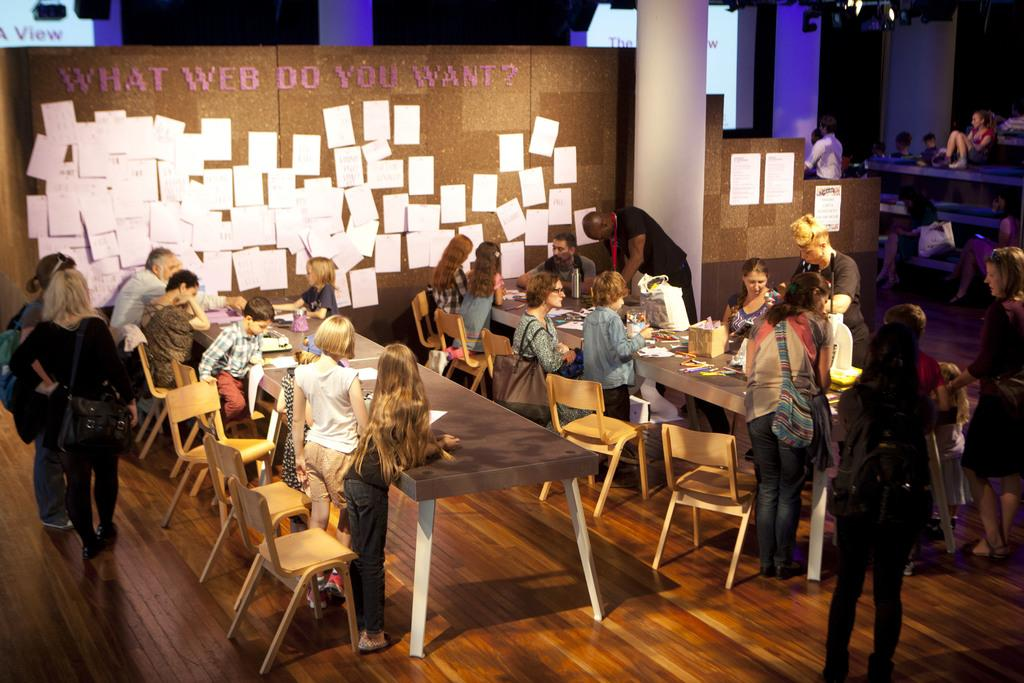How many people are in the image? There are people in the image, but the exact number is not specified. What are the people in the image doing? Some people are sitting, while others are standing. What type of furniture is present in the image? There are chairs and tables in the image. What can be seen in the background of the image? Papers are visible in the background of the image. How many apples are on the table in the image? There is no mention of apples in the image, so we cannot determine the number of apples present. What type of baseball equipment can be seen in the image? There is no mention of baseball equipment in the image, so we cannot determine if any is present. 